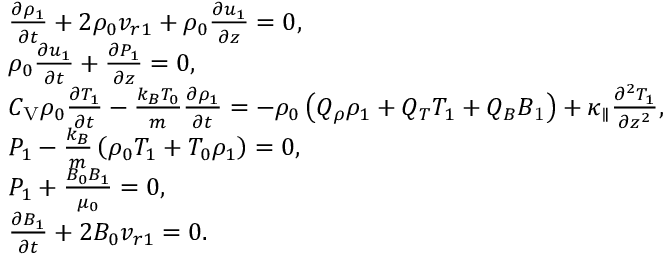Convert formula to latex. <formula><loc_0><loc_0><loc_500><loc_500>\begin{array} { r l } & { \frac { \partial \rho _ { 1 } } { \partial t } + 2 \rho _ { 0 } v _ { r 1 } + \rho _ { 0 } \frac { \partial u _ { 1 } } { \partial z } = 0 , } \\ & { \rho _ { 0 } \frac { \partial u _ { 1 } } { \partial t } + \frac { \partial P _ { 1 } } { \partial z } = 0 , } \\ & { C _ { V } \rho _ { 0 } \frac { \partial T _ { 1 } } { \partial t } - \frac { k _ { B } T _ { 0 } } { m } \frac { \partial \rho _ { 1 } } { \partial t } = - \rho _ { 0 } \left ( Q _ { \rho } \rho _ { 1 } + Q _ { T } T _ { 1 } + Q _ { B } B _ { 1 } \right ) + \kappa _ { \| } \frac { \partial ^ { 2 } T _ { 1 } } { \partial z ^ { 2 } } , } \\ & { P _ { 1 } - \frac { k _ { B } } { m } \left ( \rho _ { 0 } T _ { 1 } + T _ { 0 } \rho _ { 1 } \right ) = 0 , } \\ & { P _ { 1 } + \frac { B _ { 0 } B _ { 1 } } { \mu _ { 0 } } = 0 , } \\ & { \frac { \partial B _ { 1 } } { \partial t } + 2 B _ { 0 } v _ { r 1 } = 0 . } \end{array}</formula> 